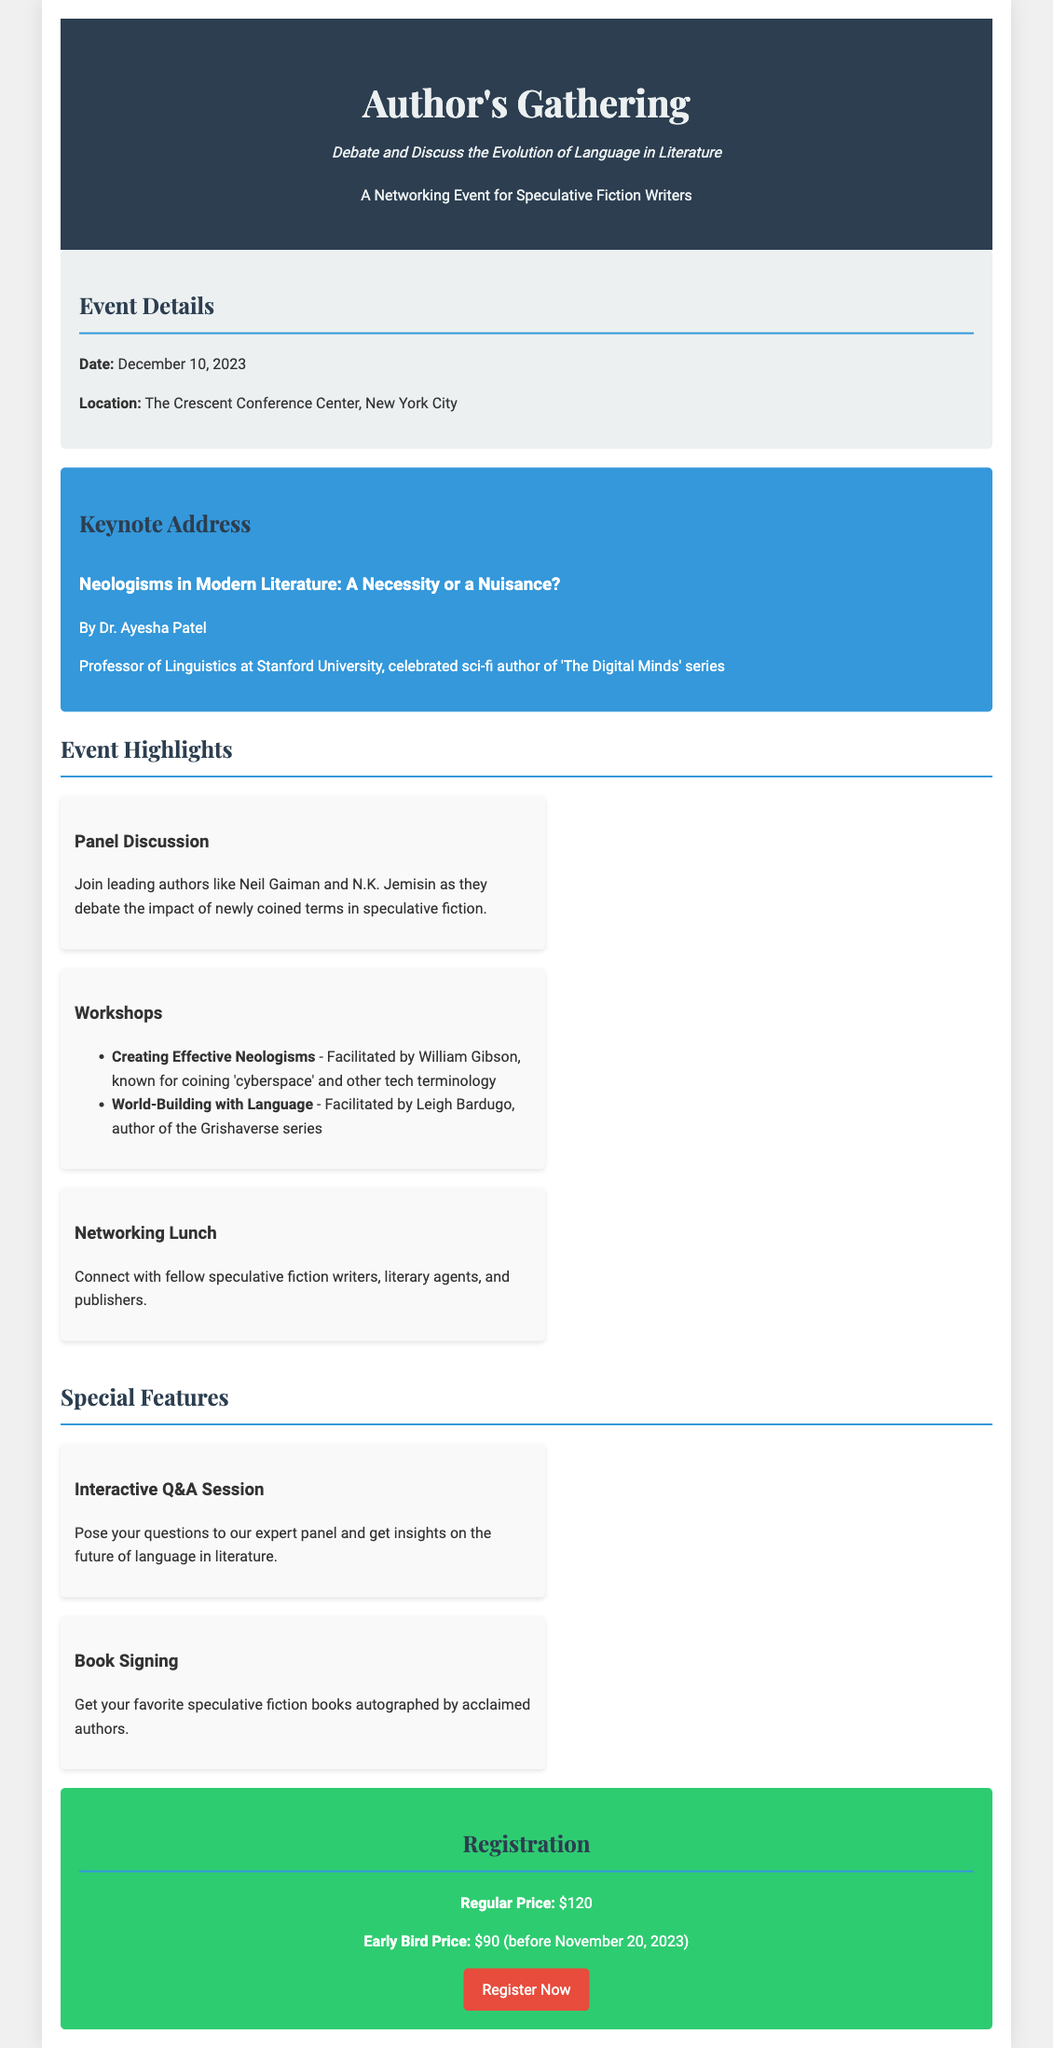What is the date of the event? The event date is specifically mentioned in the document as December 10, 2023.
Answer: December 10, 2023 Who is the keynote speaker? The keynote address mentions Dr. Ayesha Patel as the speaker, along with her credentials.
Answer: Dr. Ayesha Patel What is the location of the event? The document clearly states that the location is The Crescent Conference Center, New York City.
Answer: The Crescent Conference Center, New York City What is the early bird registration price? The document lists the early bird price for registration before November 20, 2023, which is a specific amount.
Answer: $90 Which famous authors are participating in the panel discussion? The document cites Neil Gaiman and N.K. Jemisin as participating authors in the panel discussion.
Answer: Neil Gaiman and N.K. Jemisin What workshop focuses on creating neologisms? The workshop on creating effective neologisms is specified in the highlights section of the document.
Answer: Creating Effective Neologisms What type of session allows for posing questions to the expert panel? The document describes an interactive Q&A session that allows attendees to engage with experts.
Answer: Interactive Q&A Session What is the regular registration price? The document outlines the regular price for registration, which is explicitly listed.
Answer: $120 